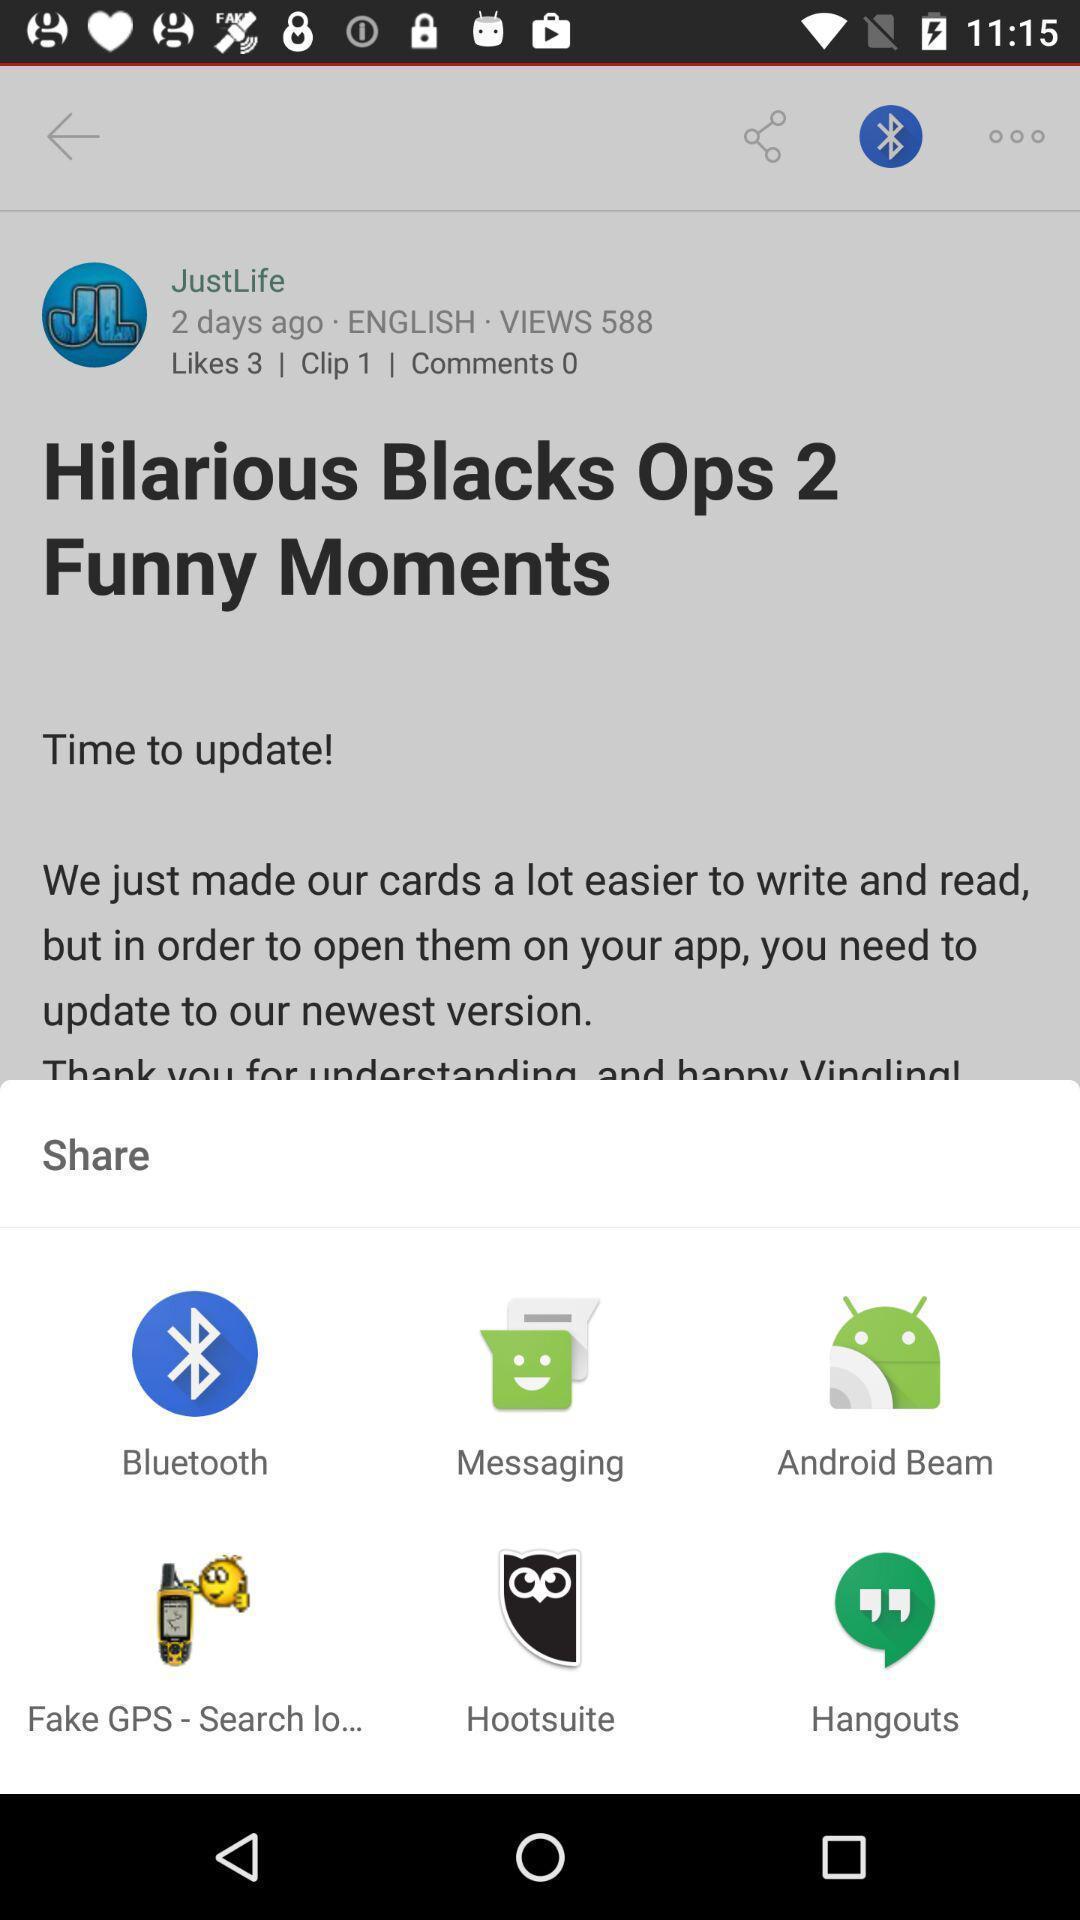Explain what's happening in this screen capture. Pop-up showing the multiple share options. 